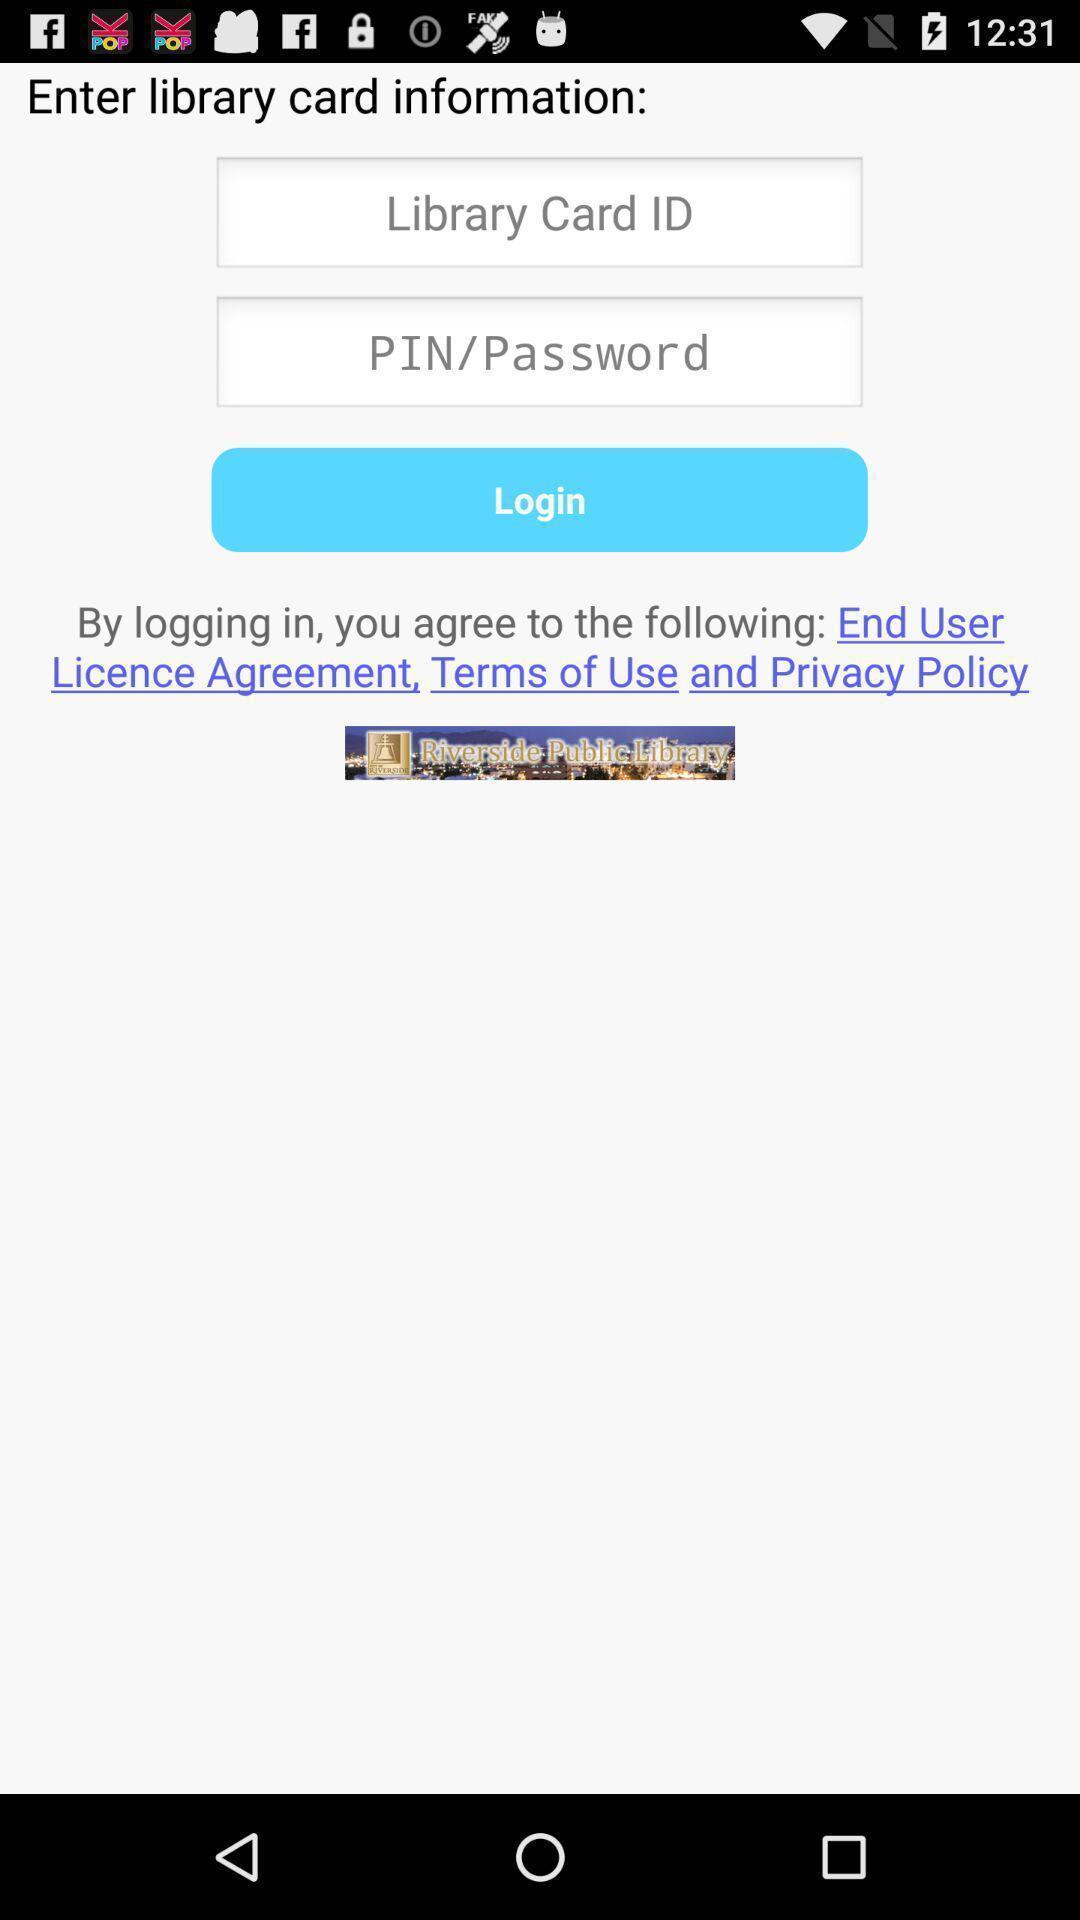Summarize the information in this screenshot. Page asking to enter library card info with log-in option. 